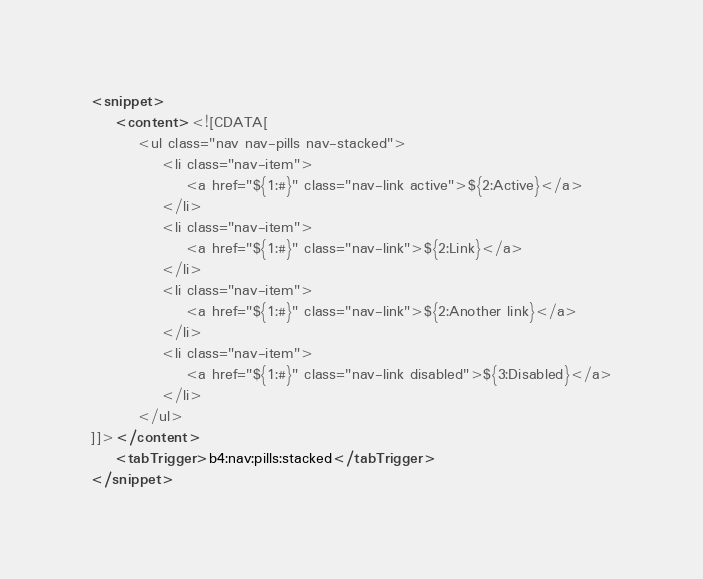Convert code to text. <code><loc_0><loc_0><loc_500><loc_500><_XML_><snippet>
	<content><![CDATA[
        <ul class="nav nav-pills nav-stacked">
			<li class="nav-item">
				<a href="${1:#}" class="nav-link active">${2:Active}</a>
			</li>
			<li class="nav-item">
				<a href="${1:#}" class="nav-link">${2:Link}</a>
			</li>
			<li class="nav-item">
				<a href="${1:#}" class="nav-link">${2:Another link}</a>
			</li>
			<li class="nav-item">
				<a href="${1:#}" class="nav-link disabled">${3:Disabled}</a>
			</li>
		</ul>
]]></content>
    <tabTrigger>b4:nav:pills:stacked</tabTrigger>
</snippet>
</code> 